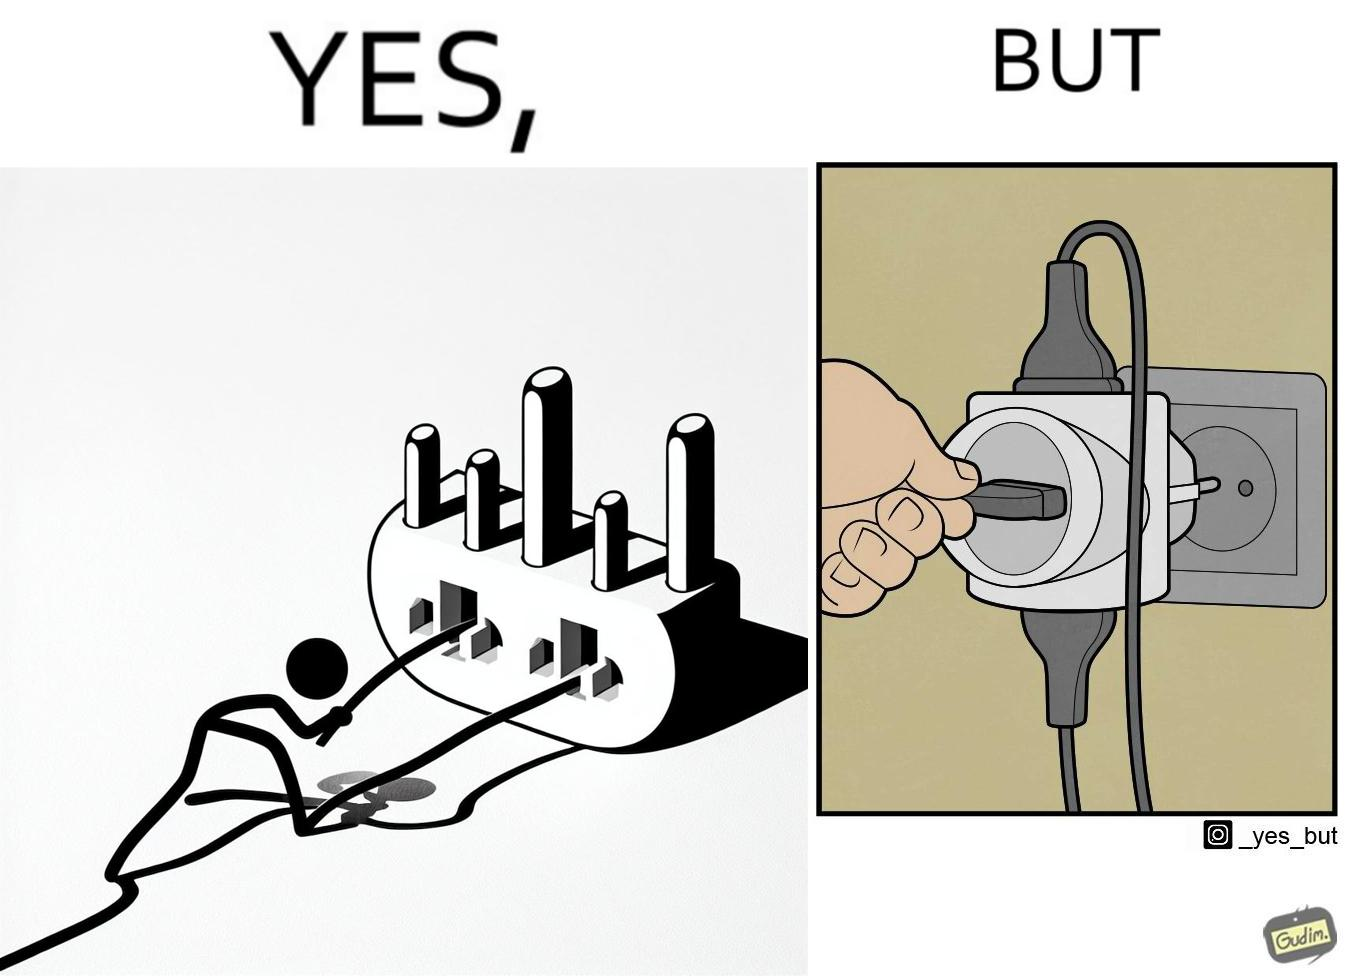What is the satirical meaning behind this image? The image is ironic, because some person is trying to plug out one pin from the multi pin plug but due to tight fitting the multi pin plug socket itself is getting pulled off disconnecting the power supply to other devices even when it is not required 